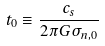Convert formula to latex. <formula><loc_0><loc_0><loc_500><loc_500>t _ { 0 } \equiv \frac { c _ { s } } { 2 \pi G \sigma _ { n , 0 } }</formula> 